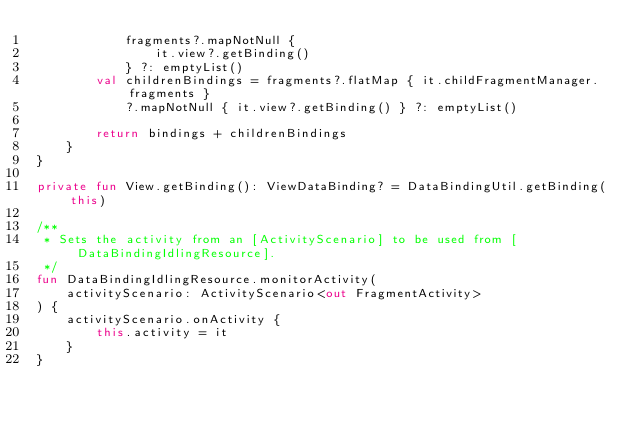Convert code to text. <code><loc_0><loc_0><loc_500><loc_500><_Kotlin_>            fragments?.mapNotNull {
                it.view?.getBinding()
            } ?: emptyList()
        val childrenBindings = fragments?.flatMap { it.childFragmentManager.fragments }
            ?.mapNotNull { it.view?.getBinding() } ?: emptyList()

        return bindings + childrenBindings
    }
}

private fun View.getBinding(): ViewDataBinding? = DataBindingUtil.getBinding(this)

/**
 * Sets the activity from an [ActivityScenario] to be used from [DataBindingIdlingResource].
 */
fun DataBindingIdlingResource.monitorActivity(
    activityScenario: ActivityScenario<out FragmentActivity>
) {
    activityScenario.onActivity {
        this.activity = it
    }
}
</code> 